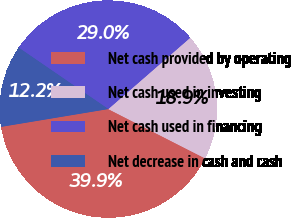Convert chart to OTSL. <chart><loc_0><loc_0><loc_500><loc_500><pie_chart><fcel>Net cash provided by operating<fcel>Net cash used in investing<fcel>Net cash used in financing<fcel>Net decrease in cash and cash<nl><fcel>39.88%<fcel>18.9%<fcel>29.04%<fcel>12.18%<nl></chart> 